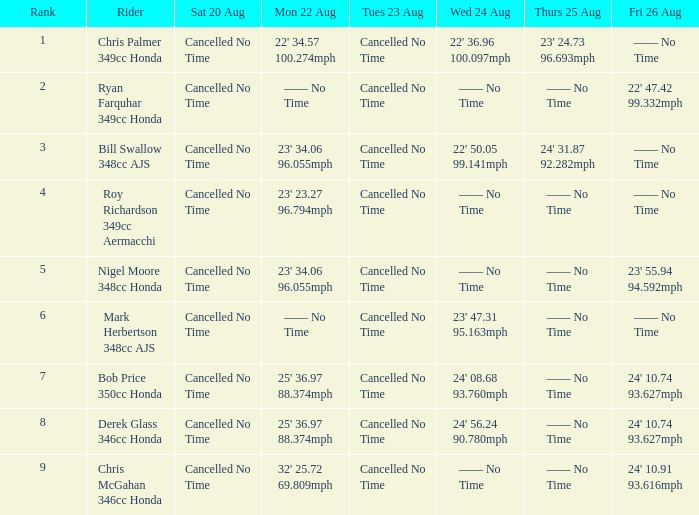809mph? 24' 10.91 93.616mph. 